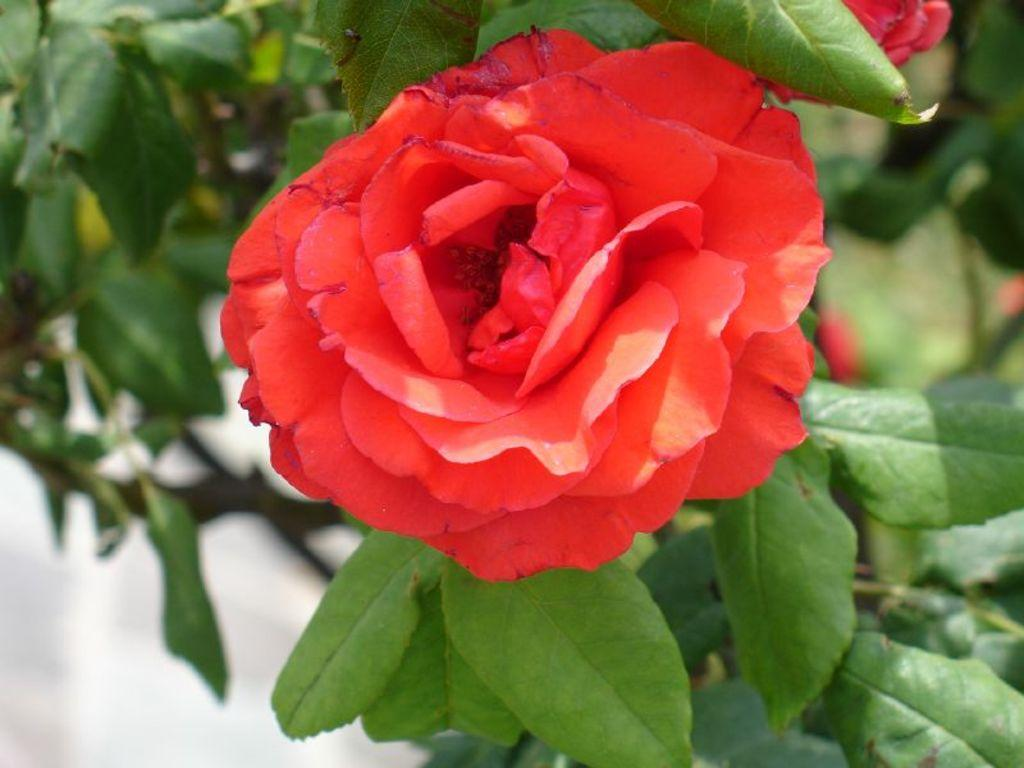What type of plant life can be seen in the image? There are flowers and leaves in the image. Can you describe the flowers in the image? Unfortunately, the facts provided do not give specific details about the flowers. What is the color of the leaves in the image? The facts provided do not specify the color of the leaves. What type of nerve is visible in the image? There is no nerve present in the image; it features flowers and leaves. How much tax is being paid for the flowers in the image? There is no indication of tax or any financial transaction related to the flowers in the image. 